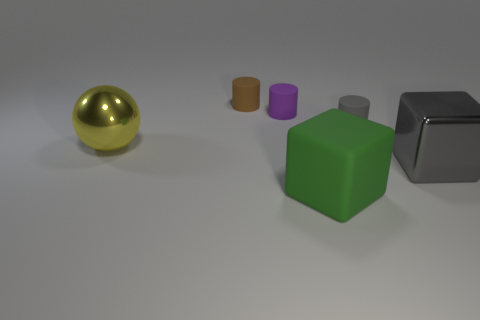Add 1 large matte objects. How many objects exist? 7 Subtract all blocks. How many objects are left? 4 Subtract all rubber things. Subtract all large red metal cylinders. How many objects are left? 2 Add 1 green cubes. How many green cubes are left? 2 Add 4 big shiny cubes. How many big shiny cubes exist? 5 Subtract 0 cyan cylinders. How many objects are left? 6 